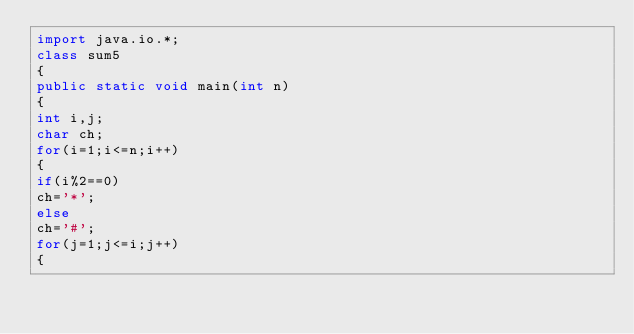<code> <loc_0><loc_0><loc_500><loc_500><_Java_>import java.io.*;
class sum5
{
public static void main(int n)
{
int i,j;
char ch;
for(i=1;i<=n;i++)
{
if(i%2==0)
ch='*';
else
ch='#';
for(j=1;j<=i;j++)
{</code> 